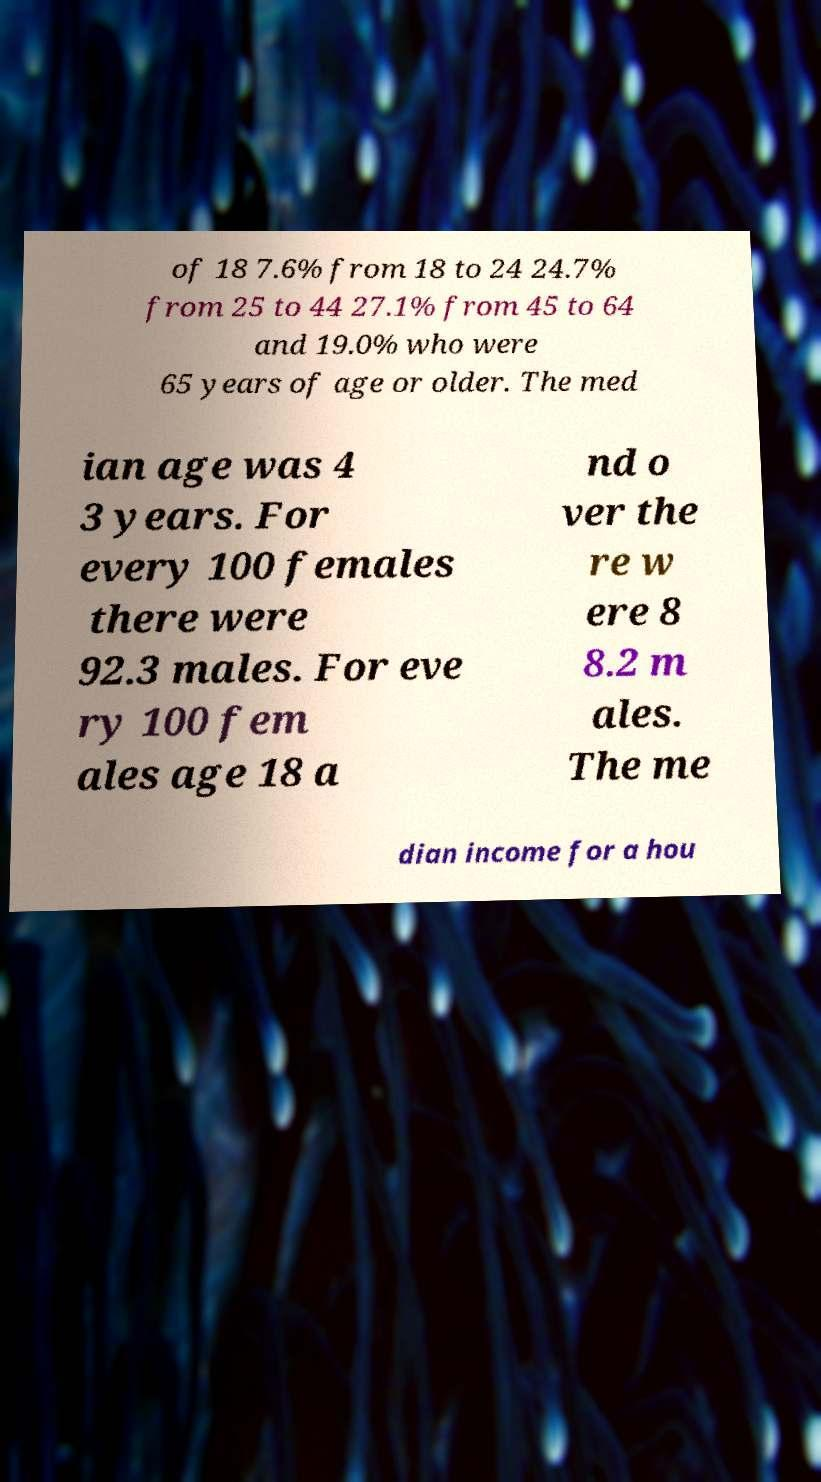There's text embedded in this image that I need extracted. Can you transcribe it verbatim? of 18 7.6% from 18 to 24 24.7% from 25 to 44 27.1% from 45 to 64 and 19.0% who were 65 years of age or older. The med ian age was 4 3 years. For every 100 females there were 92.3 males. For eve ry 100 fem ales age 18 a nd o ver the re w ere 8 8.2 m ales. The me dian income for a hou 